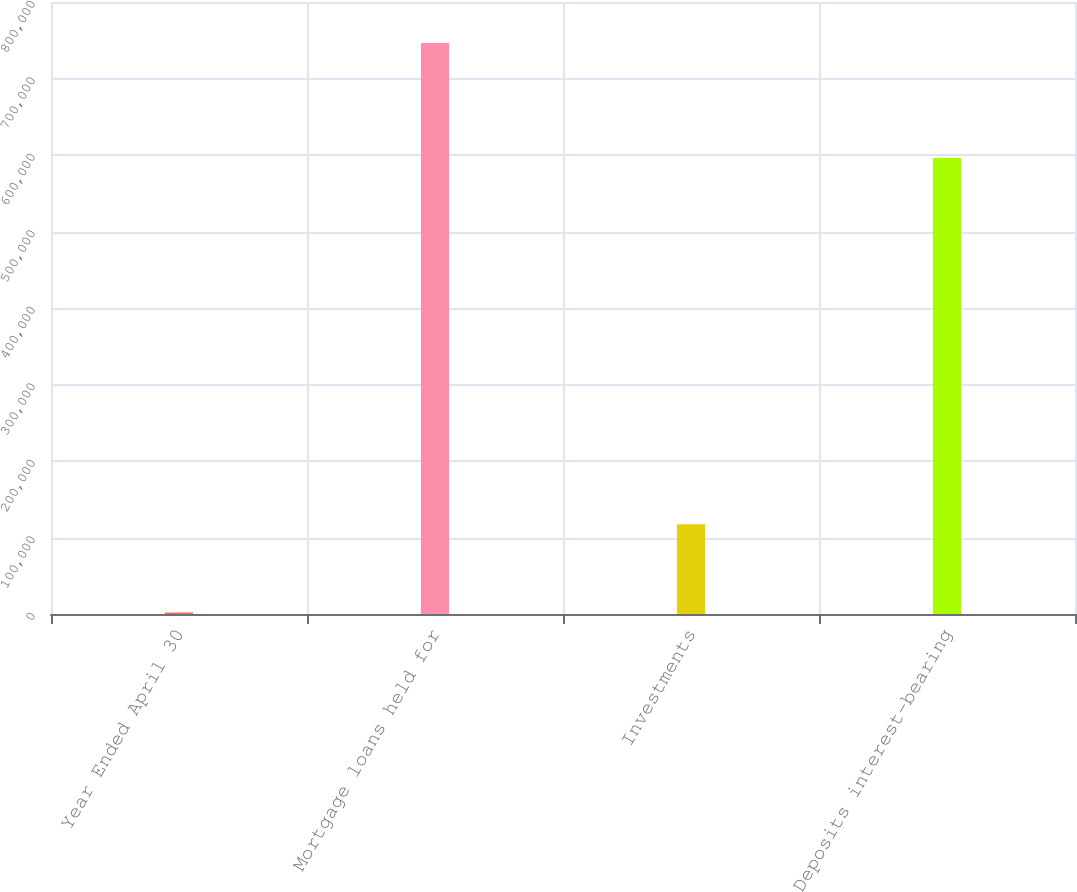Convert chart to OTSL. <chart><loc_0><loc_0><loc_500><loc_500><bar_chart><fcel>Year Ended April 30<fcel>Mortgage loans held for<fcel>Investments<fcel>Deposits interest-bearing<nl><fcel>2007<fcel>746387<fcel>117350<fcel>596104<nl></chart> 